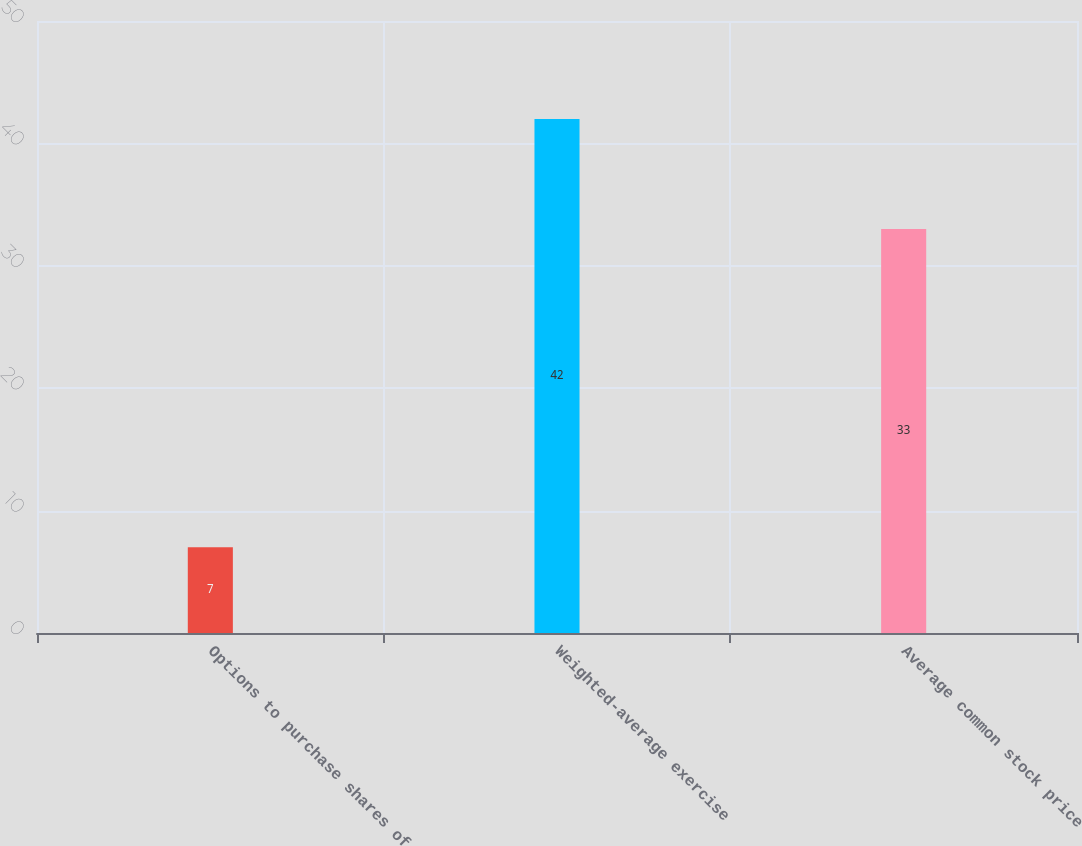Convert chart. <chart><loc_0><loc_0><loc_500><loc_500><bar_chart><fcel>Options to purchase shares of<fcel>Weighted-average exercise<fcel>Average common stock price<nl><fcel>7<fcel>42<fcel>33<nl></chart> 